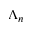<formula> <loc_0><loc_0><loc_500><loc_500>\Lambda _ { n }</formula> 